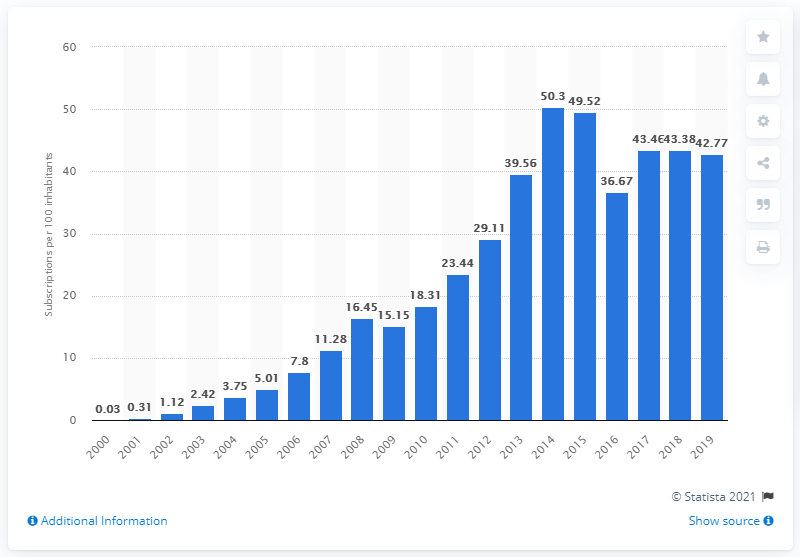Specify some key components in this picture. In the Democratic Republic of the Congo between 2000 and 2019, there were an average of 42.77 mobile subscriptions registered for every 100 people. In the Democratic Republic of the Congo, the number of mobile cellular subscriptions per 100 inhabitants was between 2000 and . 